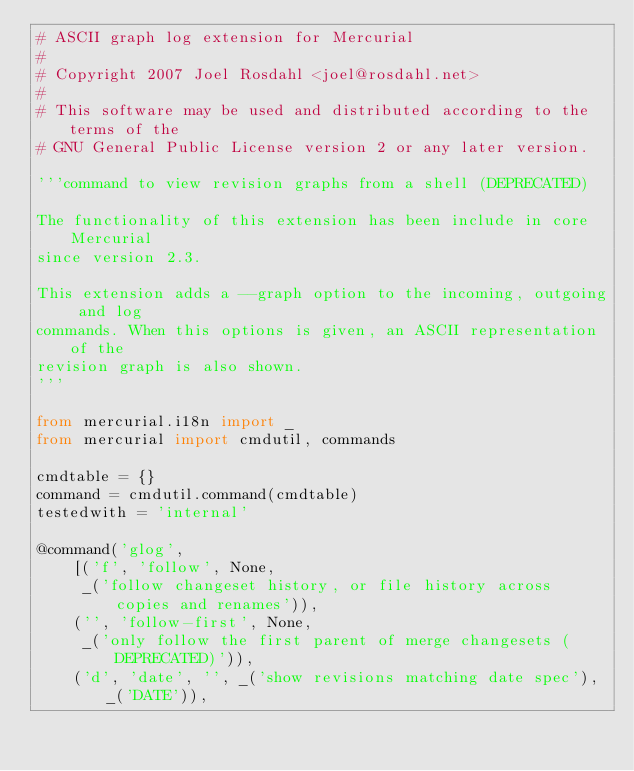<code> <loc_0><loc_0><loc_500><loc_500><_Python_># ASCII graph log extension for Mercurial
#
# Copyright 2007 Joel Rosdahl <joel@rosdahl.net>
#
# This software may be used and distributed according to the terms of the
# GNU General Public License version 2 or any later version.

'''command to view revision graphs from a shell (DEPRECATED)

The functionality of this extension has been include in core Mercurial
since version 2.3.

This extension adds a --graph option to the incoming, outgoing and log
commands. When this options is given, an ASCII representation of the
revision graph is also shown.
'''

from mercurial.i18n import _
from mercurial import cmdutil, commands

cmdtable = {}
command = cmdutil.command(cmdtable)
testedwith = 'internal'

@command('glog',
    [('f', 'follow', None,
     _('follow changeset history, or file history across copies and renames')),
    ('', 'follow-first', None,
     _('only follow the first parent of merge changesets (DEPRECATED)')),
    ('d', 'date', '', _('show revisions matching date spec'), _('DATE')),</code> 